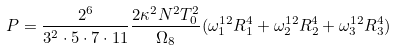<formula> <loc_0><loc_0><loc_500><loc_500>P = \frac { 2 ^ { 6 } } { 3 ^ { 2 } \cdot 5 \cdot 7 \cdot 1 1 } \frac { 2 \kappa ^ { 2 } N ^ { 2 } T _ { 0 } ^ { 2 } } { \Omega _ { 8 } } ( \omega _ { 1 } ^ { 1 2 } R _ { 1 } ^ { 4 } + \omega _ { 2 } ^ { 1 2 } R _ { 2 } ^ { 4 } + \omega _ { 3 } ^ { 1 2 } R _ { 3 } ^ { 4 } )</formula> 